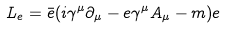Convert formula to latex. <formula><loc_0><loc_0><loc_500><loc_500>L _ { e } = \bar { e } ( i \gamma ^ { \mu } \partial _ { \mu } - e \gamma ^ { \mu } A _ { \mu } - m ) e</formula> 